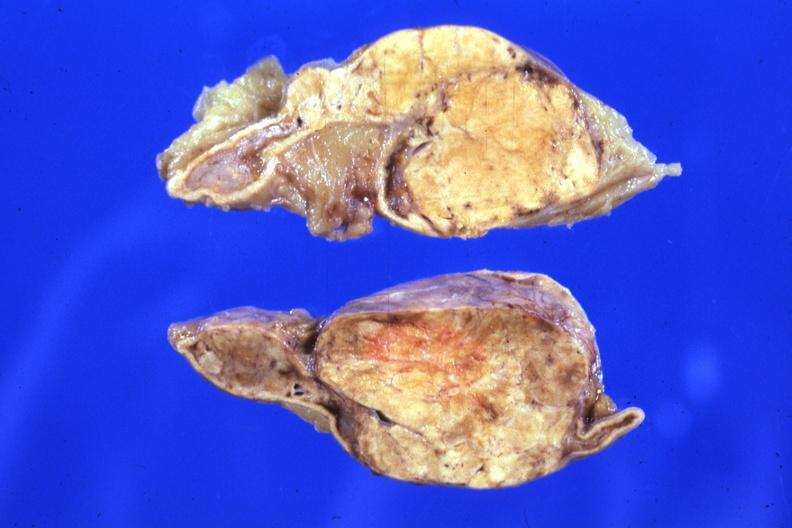s endocrine present?
Answer the question using a single word or phrase. Yes 